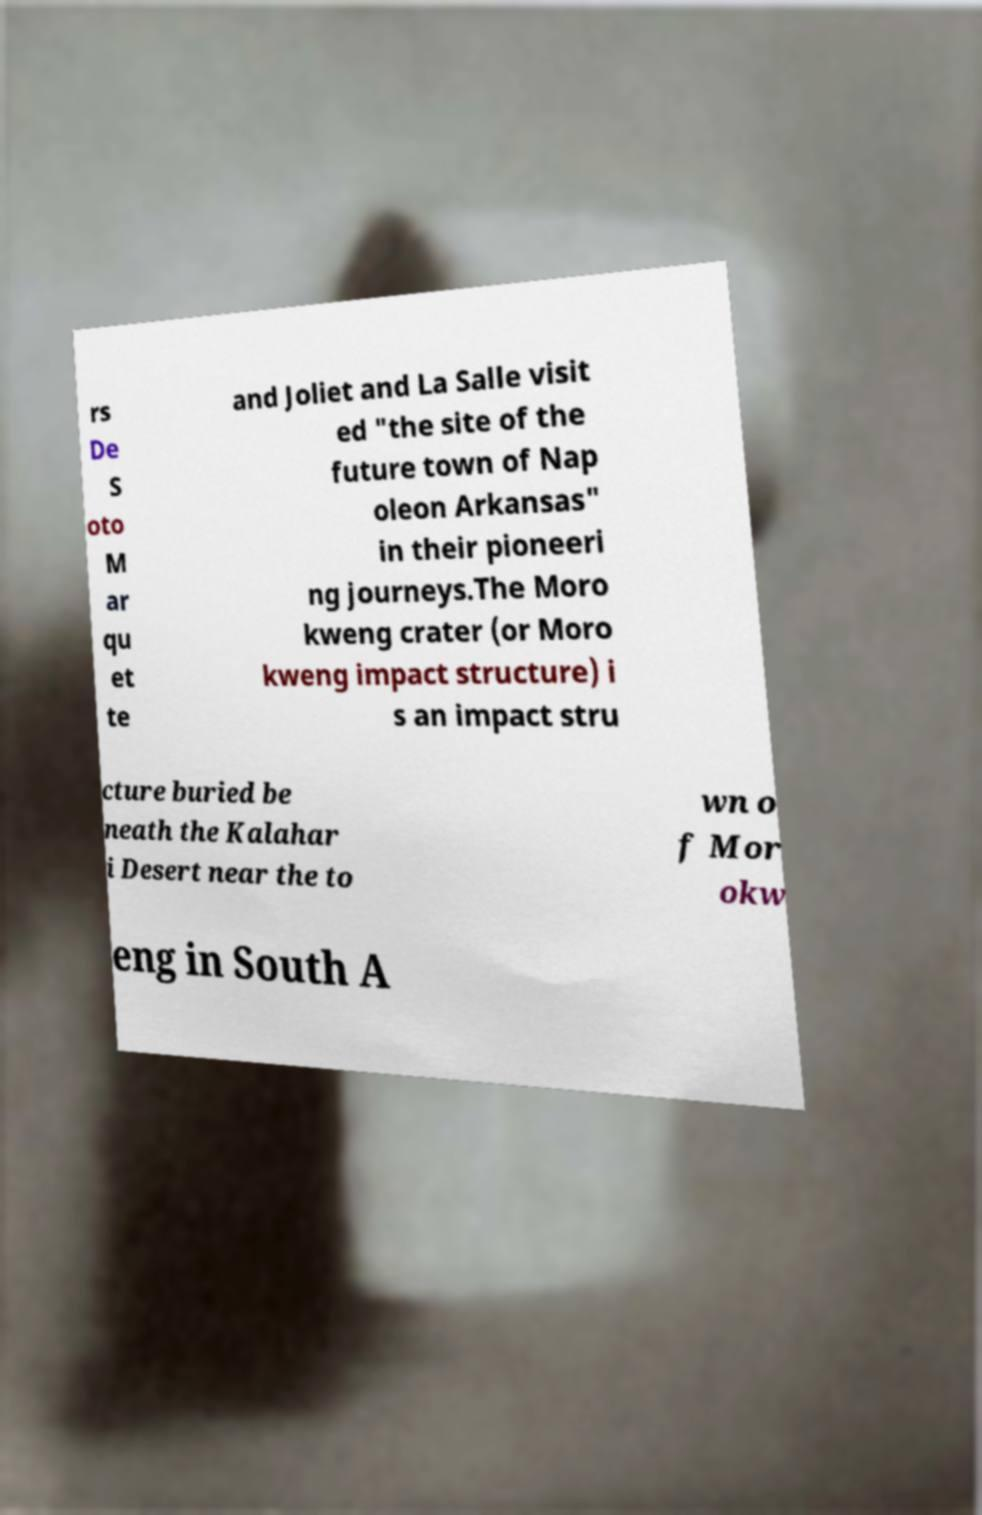Please identify and transcribe the text found in this image. rs De S oto M ar qu et te and Joliet and La Salle visit ed "the site of the future town of Nap oleon Arkansas" in their pioneeri ng journeys.The Moro kweng crater (or Moro kweng impact structure) i s an impact stru cture buried be neath the Kalahar i Desert near the to wn o f Mor okw eng in South A 